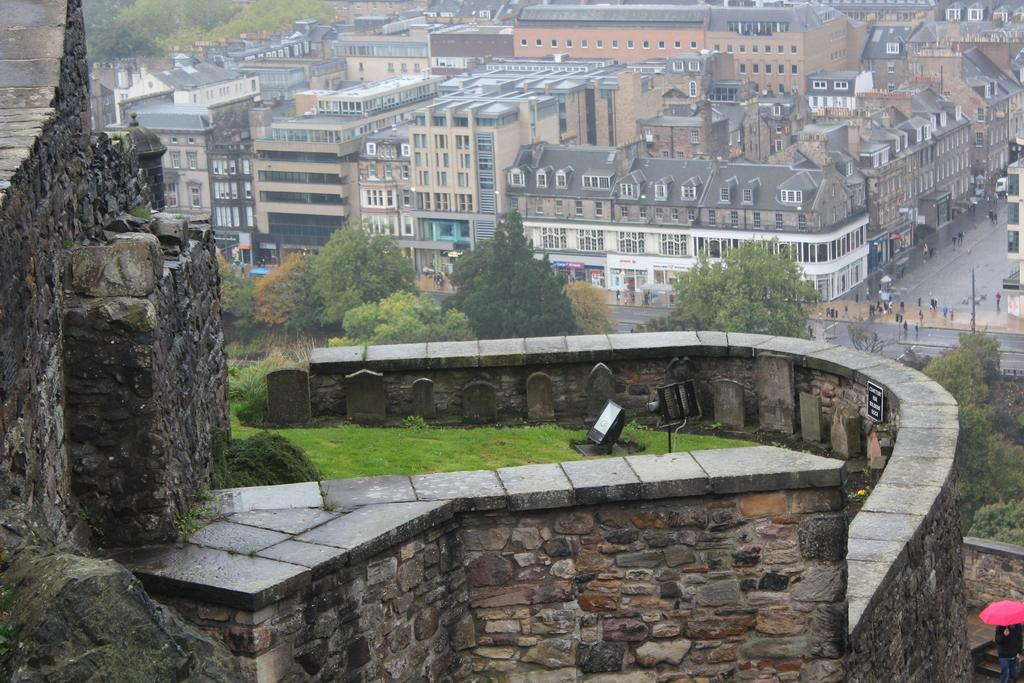What type of vegetation is present in the image? There is grass in the image. What other natural elements can be seen in the image? There are trees in the image. What can be seen in the distance in the image? There are buildings in the background of the image. Who or what is present on the road in the image? There are people visible on the road in the image. What type of fireman is measuring the grass in the image? There is no fireman present in the image, nor is anyone measuring the grass. 